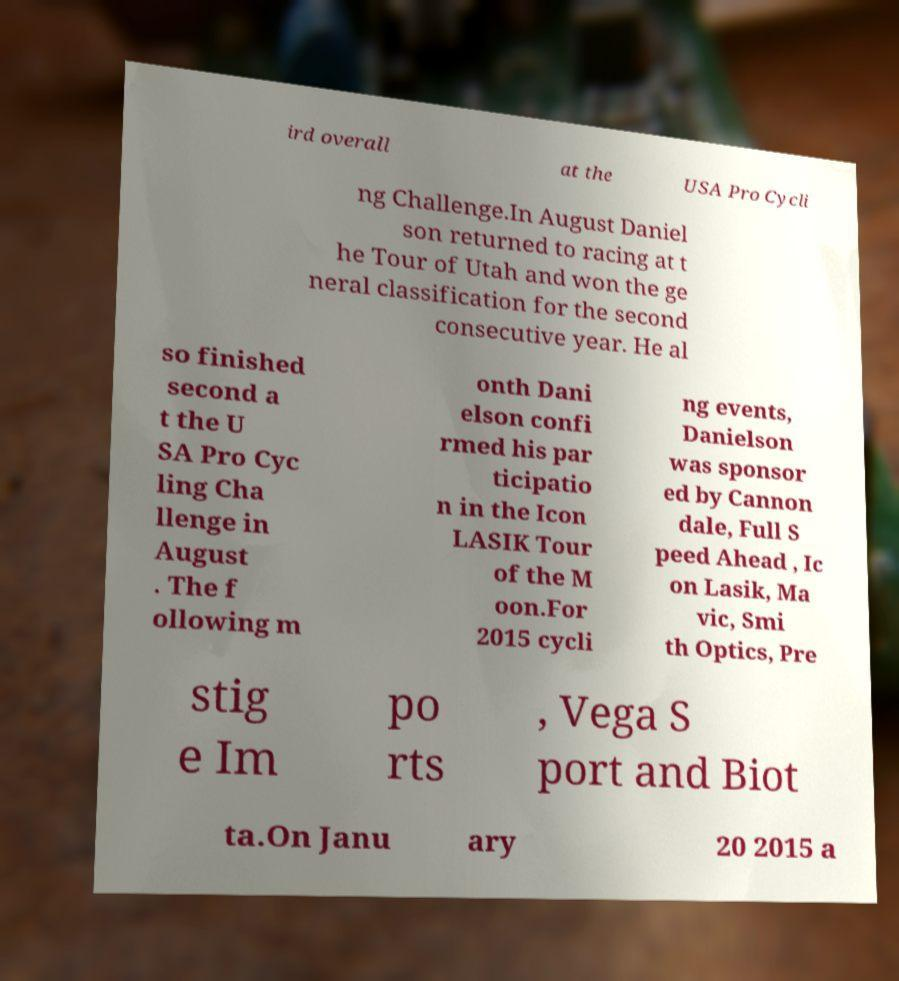What messages or text are displayed in this image? I need them in a readable, typed format. ird overall at the USA Pro Cycli ng Challenge.In August Daniel son returned to racing at t he Tour of Utah and won the ge neral classification for the second consecutive year. He al so finished second a t the U SA Pro Cyc ling Cha llenge in August . The f ollowing m onth Dani elson confi rmed his par ticipatio n in the Icon LASIK Tour of the M oon.For 2015 cycli ng events, Danielson was sponsor ed by Cannon dale, Full S peed Ahead , Ic on Lasik, Ma vic, Smi th Optics, Pre stig e Im po rts , Vega S port and Biot ta.On Janu ary 20 2015 a 